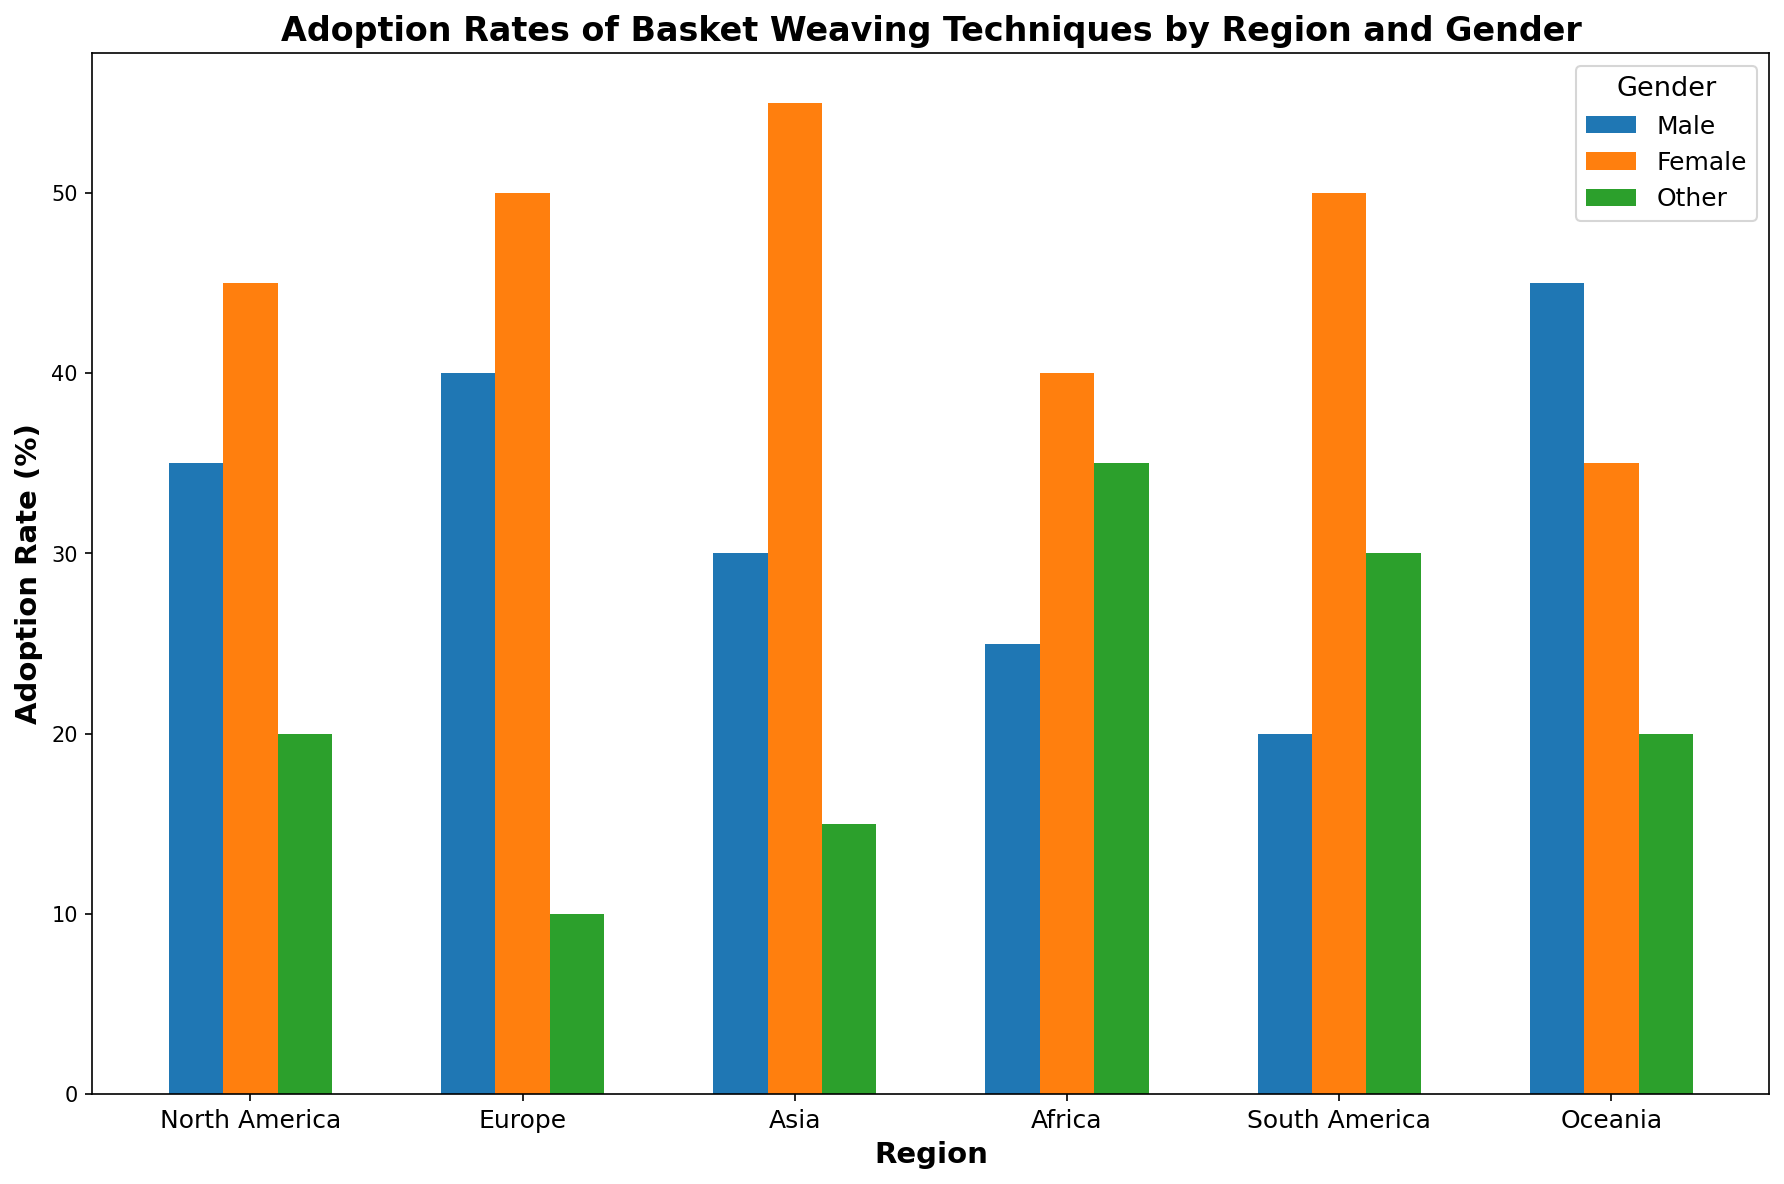Which region has the highest adoption rate for females? By examining the heights of the bars corresponding to females in all regions, it's evident that Asia has the highest adoption rate of 55%.
Answer: Asia Which gender has the lowest adoption rate in Oceania? Comparing the three gender bars in Oceania, other has the lowest adoption rate of 20%.
Answer: Other What is the total adoption rate for basket weaving techniques in North America across all genders? Adding the adoption rates for males (35%), females (45%), and others (20%) in North America, the total is 35 + 45 + 20 = 100%.
Answer: 100% How does the adoption rate for males in Europe compare to that in North America? The adoption rate for males in Europe is 40%, and in North America, it's 35%. Therefore, Europe’s rate is higher by 40 - 35 = 5%.
Answer: Europe is higher by 5% What is the average adoption rate for females across all regions? Adding the adoption rates for females in each region (North America: 45%, Europe: 50%, Asia: 55%, Africa: 40%, South America: 50%, Oceania: 35%) and dividing by the number of regions (6): (45 + 50 + 55 + 40 + 50 + 35) / 6 = 275 / 6 ≈ 45.83%.
Answer: ≈ 45.83% Which region has the largest disparity in adoption rates between genders? Calculating the differences between the highest and lowest adoption rates for each region:
- North America: 45% (Female) - 20% (Other) = 25%
- Europe: 50% (Female) - 10% (Other) = 40%
- Asia: 55% (Female) - 15% (Other) = 40%
- Africa: 40% (Female) - 25% (Male) = 15%
- South America: 50% (Female) - 20% (Male) = 30%
- Oceania: 45% (Male) - 20% (Other) = 25%
Europe and Asia have the largest disparity of 40%.
Answer: Europe and Asia What is the combined adoption rate for males and others in Africa? Adding the adoption rates for males (25%) and others (35%) in Africa: 25 + 35 = 60%.
Answer: 60% Which gender generally shows the least variability in adoption rates across all regions? Comparing variability by examining the heights of bars:
Males vary from 20% to 45% (25% range), Females vary from 35% to 55% (20% range), and Others vary from 10% to 35% (25% range). Females show the least variability with a 20% range.
Answer: Females 